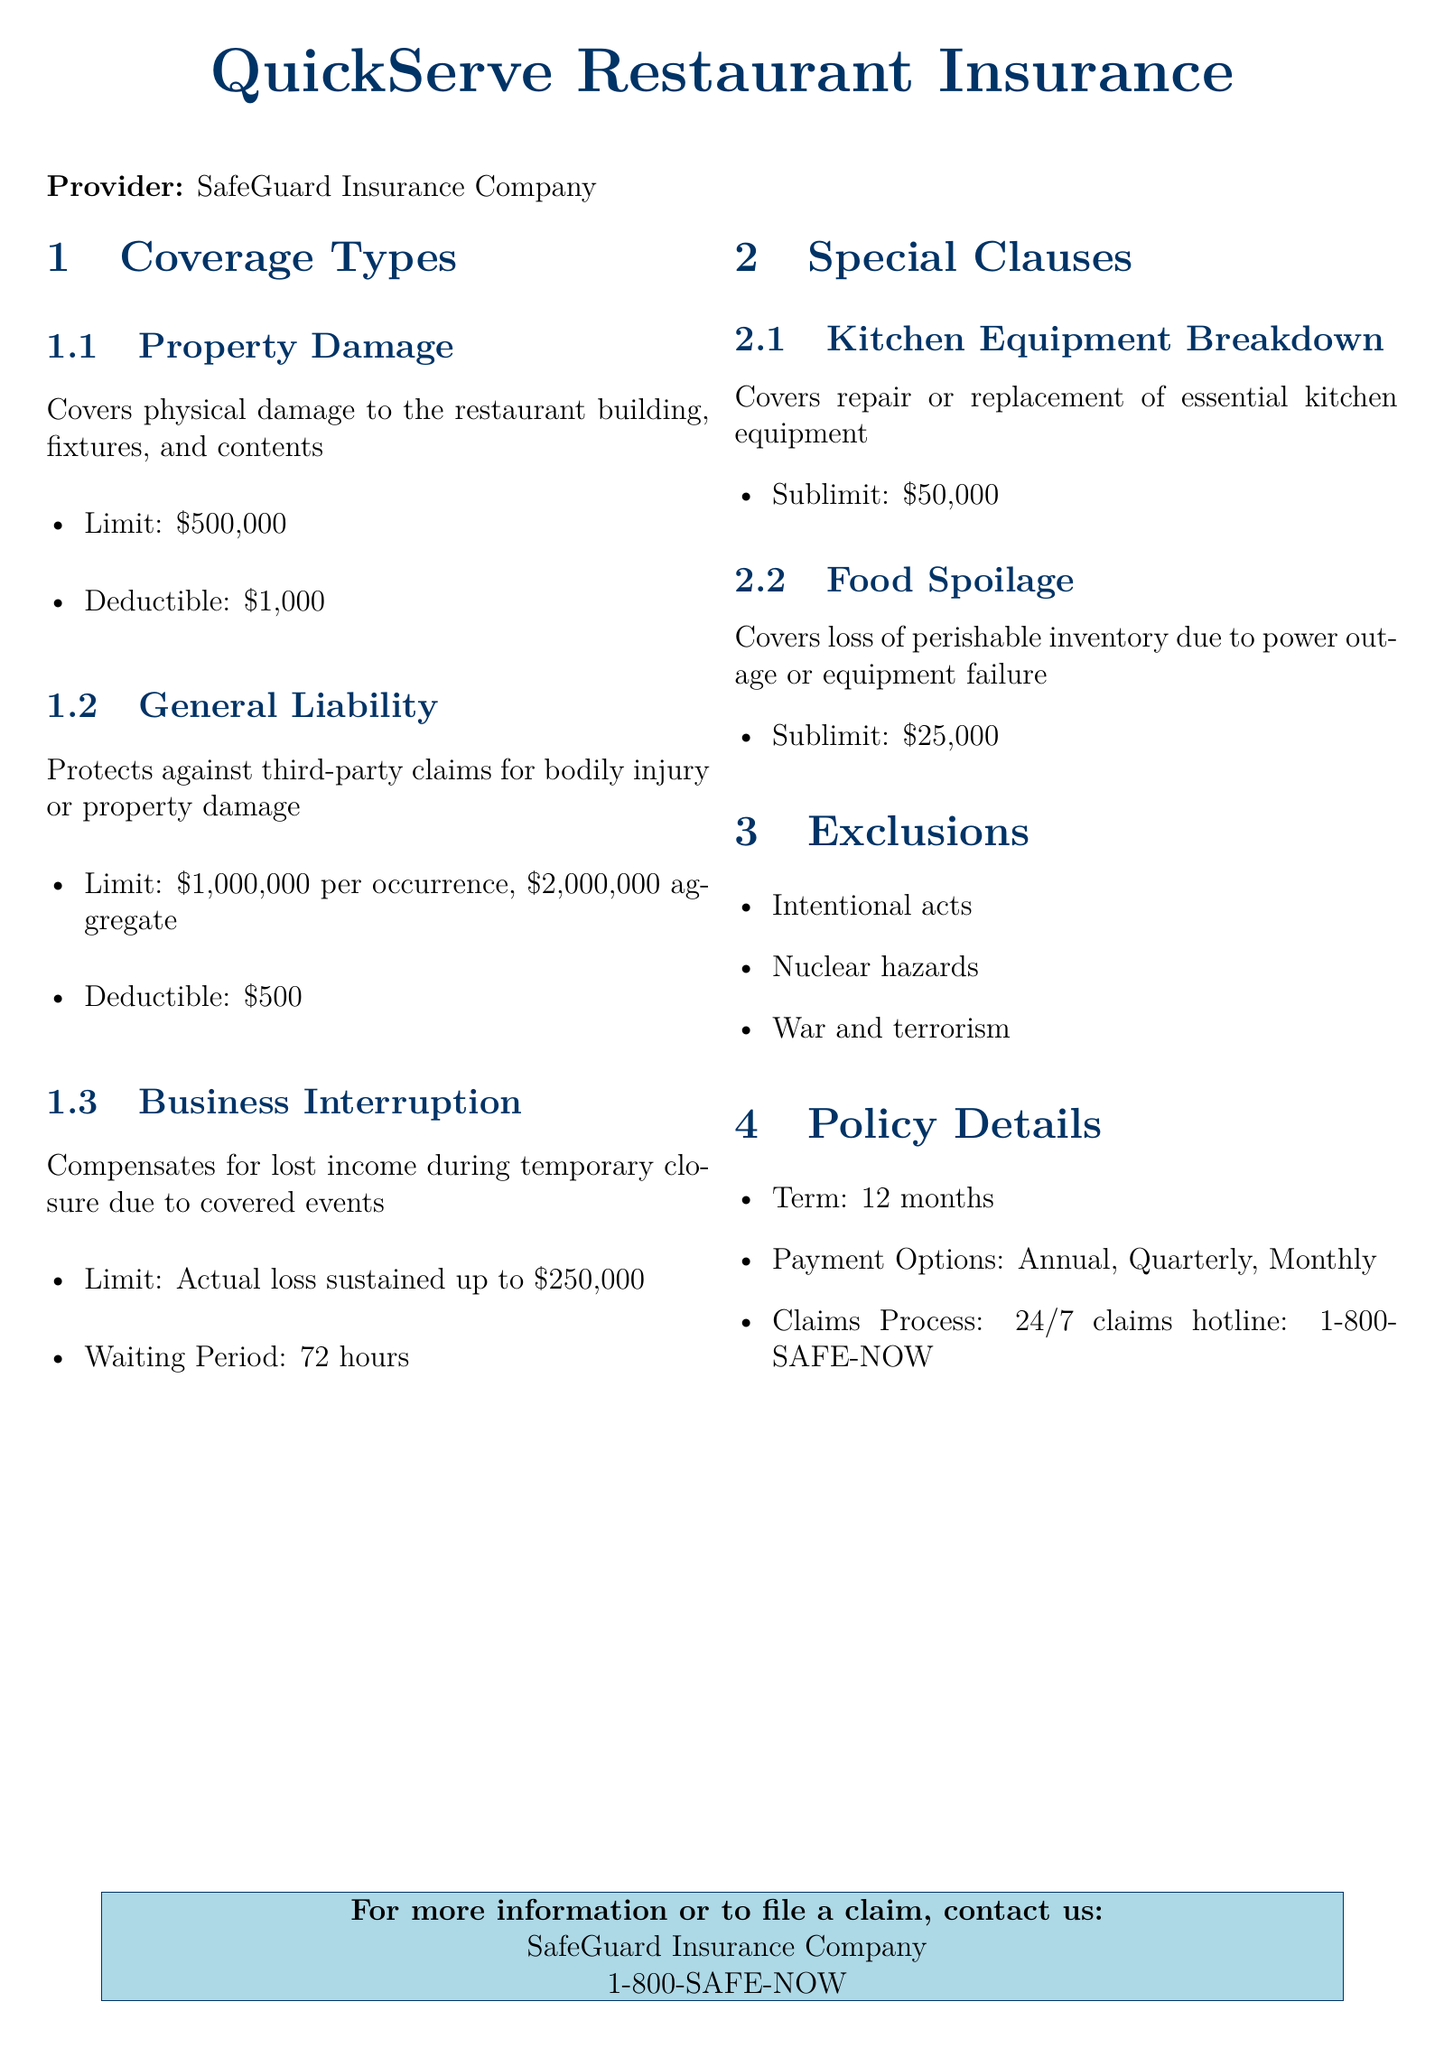What is the limit for property damage coverage? The limit for property damage coverage is explicitly stated in the coverage section, which is $500,000.
Answer: $500,000 What is the deductible for general liability coverage? The deductible for general liability coverage can be found under its specific section, which is $500.
Answer: $500 What is the waiting period for business interruption coverage? The waiting period is mentioned under the business interruption section as 72 hours.
Answer: 72 hours What is the sublimit for kitchen equipment breakdown? The sublimit for kitchen equipment breakdown is listed in the special clauses section as $50,000.
Answer: $50,000 What type of claims does general liability coverage protect against? General liability coverage protects against third-party claims for bodily injury or property damage.
Answer: Bodily injury or property damage What is the term of the insurance policy? The term of the insurance policy is detailed in the policy details section as 12 months.
Answer: 12 months What is the sublimit for food spoilage coverage? The sublimit for food spoilage coverage is explicitly stated as $25,000 in the document.
Answer: $25,000 What is the phone number for the claims process? The claims process contact number is outlined in the document as 1-800-SAFE-NOW.
Answer: 1-800-SAFE-NOW What are the exclusions listed in the document? The document lists exclusions such as intentional acts, nuclear hazards, and war and terrorism.
Answer: Intentional acts, nuclear hazards, war and terrorism 